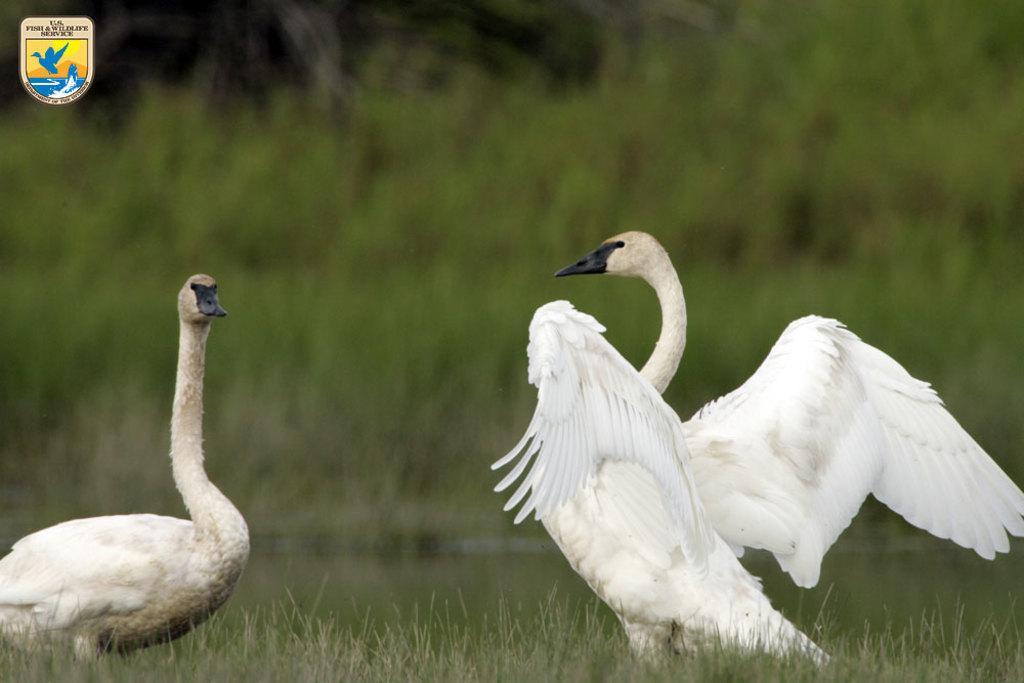In one or two sentences, can you explain what this image depicts? In the center of the image we can see swans on the grass. 